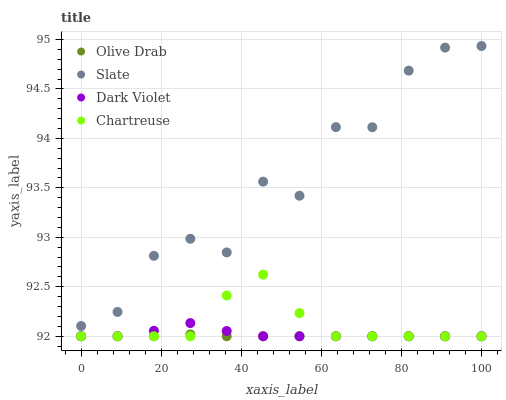Does Olive Drab have the minimum area under the curve?
Answer yes or no. Yes. Does Slate have the maximum area under the curve?
Answer yes or no. Yes. Does Dark Violet have the minimum area under the curve?
Answer yes or no. No. Does Dark Violet have the maximum area under the curve?
Answer yes or no. No. Is Olive Drab the smoothest?
Answer yes or no. Yes. Is Slate the roughest?
Answer yes or no. Yes. Is Dark Violet the smoothest?
Answer yes or no. No. Is Dark Violet the roughest?
Answer yes or no. No. Does Chartreuse have the lowest value?
Answer yes or no. Yes. Does Slate have the lowest value?
Answer yes or no. No. Does Slate have the highest value?
Answer yes or no. Yes. Does Dark Violet have the highest value?
Answer yes or no. No. Is Dark Violet less than Slate?
Answer yes or no. Yes. Is Slate greater than Dark Violet?
Answer yes or no. Yes. Does Chartreuse intersect Dark Violet?
Answer yes or no. Yes. Is Chartreuse less than Dark Violet?
Answer yes or no. No. Is Chartreuse greater than Dark Violet?
Answer yes or no. No. Does Dark Violet intersect Slate?
Answer yes or no. No. 